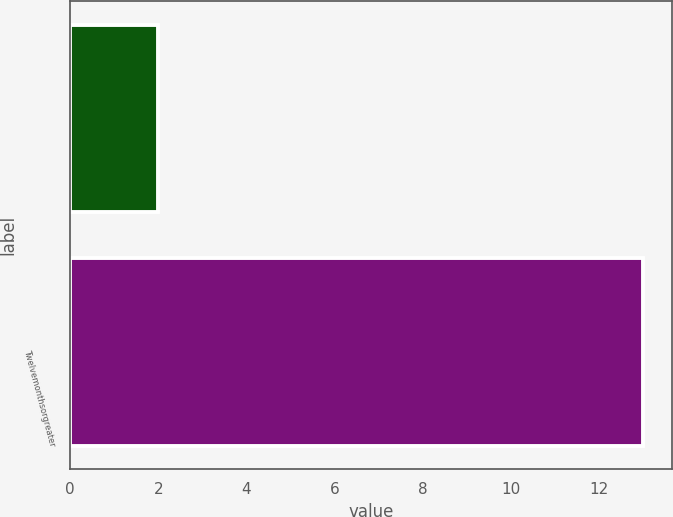<chart> <loc_0><loc_0><loc_500><loc_500><bar_chart><ecel><fcel>Twelvemonthsorgreater<nl><fcel>2<fcel>13<nl></chart> 